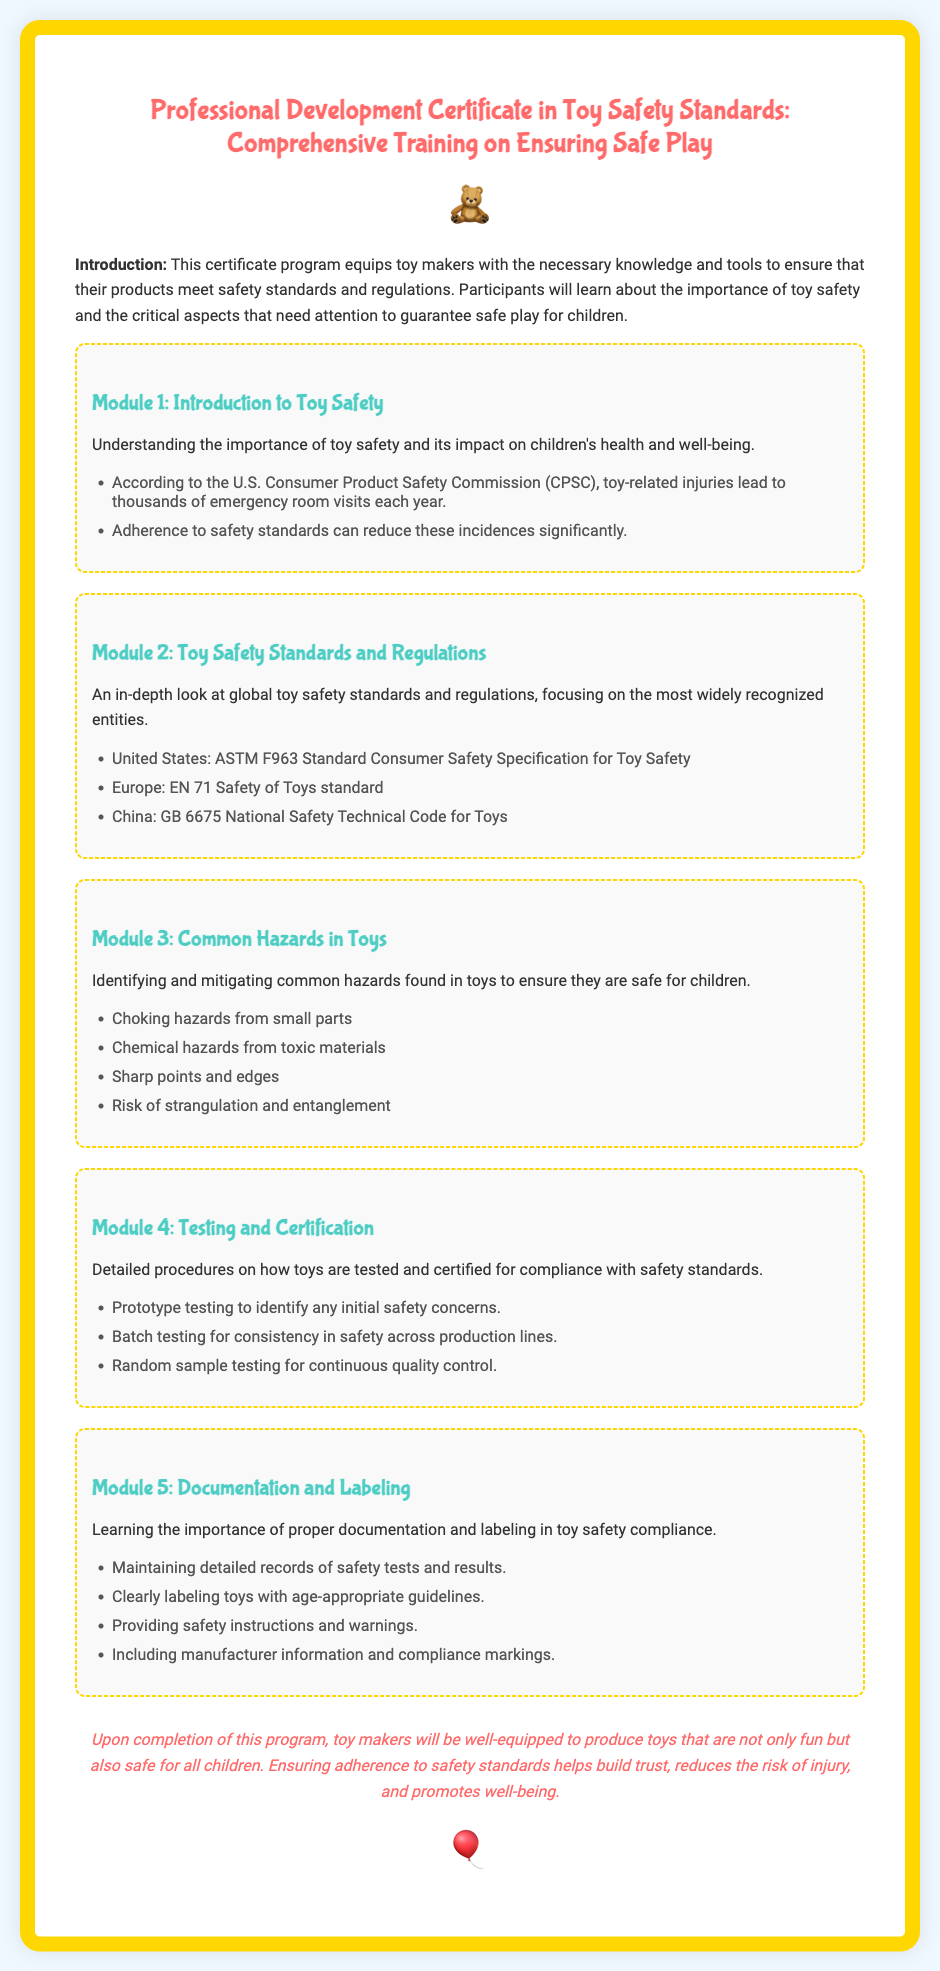What is the title of the certificate? The title of the certificate is the main heading presented at the top of the document.
Answer: Professional Development Certificate in Toy Safety Standards: Comprehensive Training on Ensuring Safe Play How many modules are in the training program? The number of modules is indicated by the individual sections within the document, each labeled as a module.
Answer: 5 Which organization’s standard is mentioned for toy safety in the United States? This detail refers to a specific standard named in the document under the module discussing regulations.
Answer: ASTM F963 What is one common hazard in toys according to the document? The document lists several hazards; this question selects one to illustrate what readers might look for.
Answer: Choking hazards from small parts What is the purpose of proper documentation and labeling? The document discusses the outcomes of good documentation practices, hinting at their significance in safety compliance.
Answer: Safety compliance What is the concluding statement of the certificate about the program’s outcome? The conclusion summarizes the overall aim and benefits of the training program as described in the document.
Answer: Safe for all children Which safety standard is referenced for toys in Europe? This question targets the specific regional standard discussed in the module on safety regulations.
Answer: EN 71 What icon is displayed at the beginning of the certificate? The document includes an icon element designed to provide visual appeal, which is noted at the top.
Answer: 🧸 